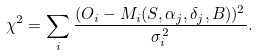<formula> <loc_0><loc_0><loc_500><loc_500>\chi ^ { 2 } = \sum _ { i } \frac { ( O _ { i } - M _ { i } ( S , \alpha _ { j } , \delta _ { j } , B ) ) ^ { 2 } } { \sigma ^ { 2 } _ { i } } .</formula> 